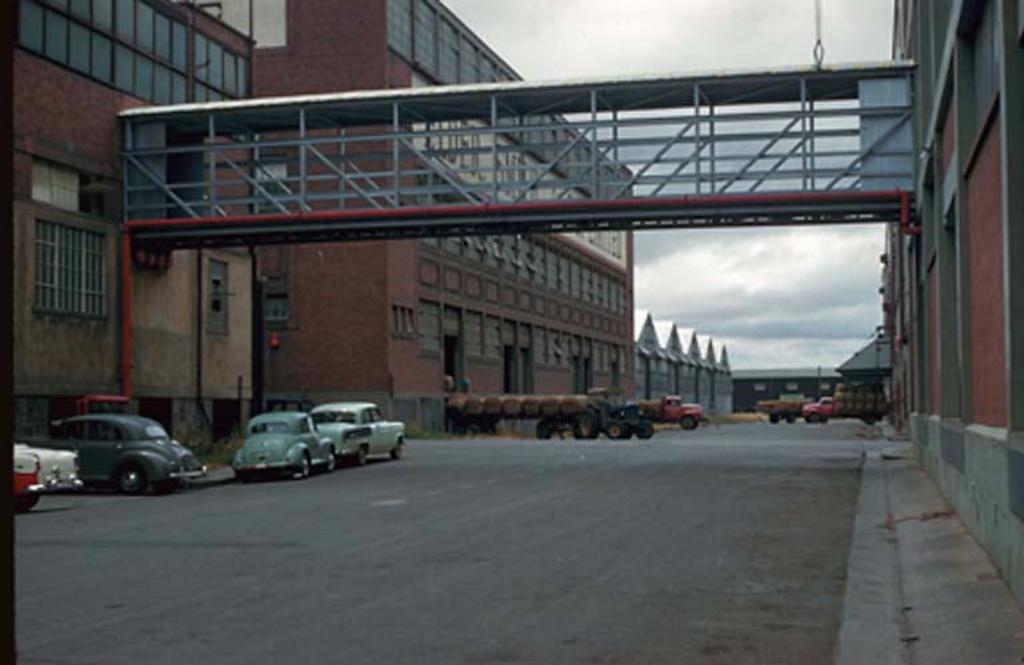What type of structure can be seen in the image? There is a bridge in the image. What else can be seen in the image besides the bridge? There are buildings, vehicles, and a road in the image. What is the condition of the sky in the image? The sky appears to be cloudy in the image. Can you describe the background of the image? The sky is visible in the background of the image. What shape is the stick used by the person in the image? There is no person or stick present in the image. What year does the image depict? The image does not have a specific year associated with it. 